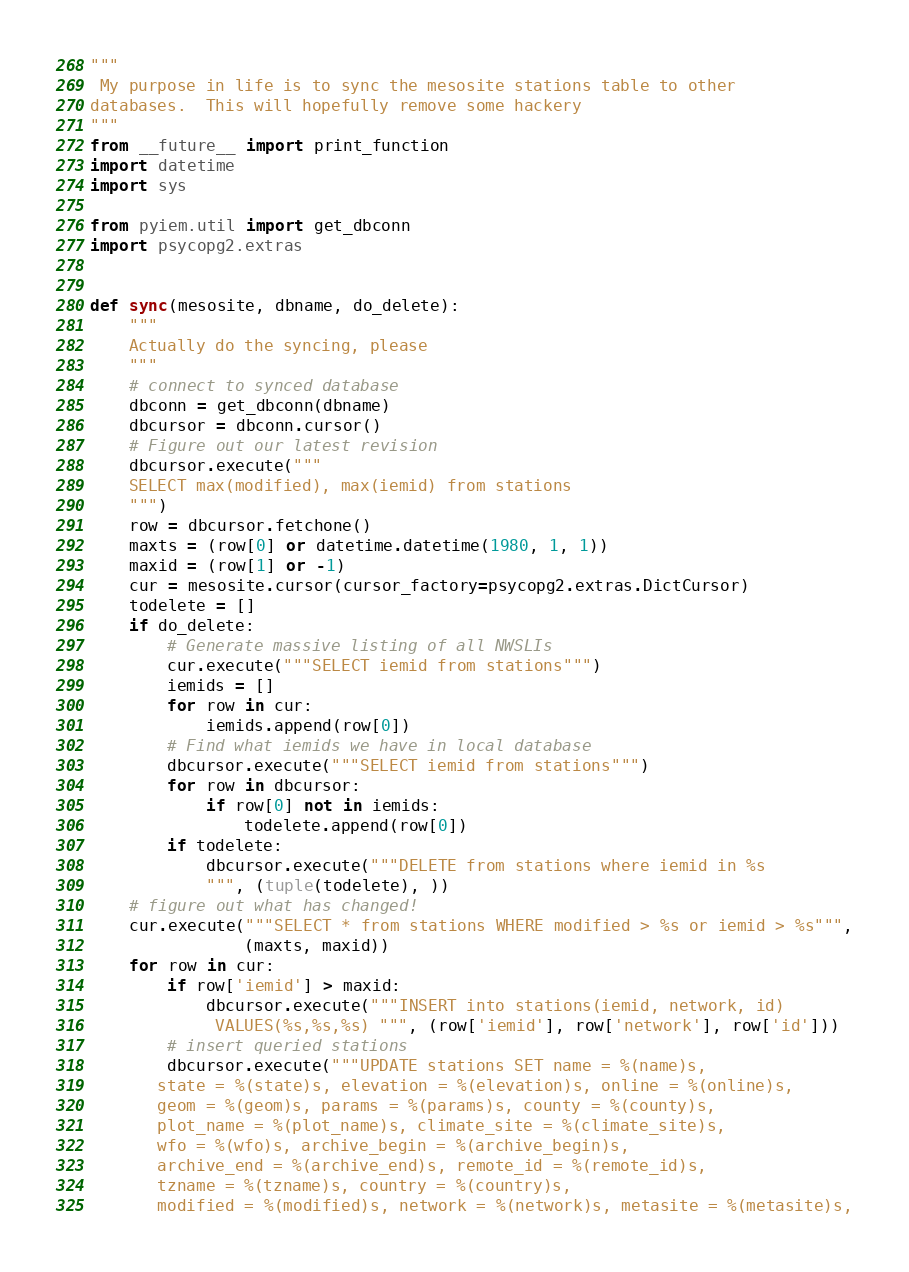<code> <loc_0><loc_0><loc_500><loc_500><_Python_>"""
 My purpose in life is to sync the mesosite stations table to other
databases.  This will hopefully remove some hackery
"""
from __future__ import print_function
import datetime
import sys

from pyiem.util import get_dbconn
import psycopg2.extras


def sync(mesosite, dbname, do_delete):
    """
    Actually do the syncing, please
    """
    # connect to synced database
    dbconn = get_dbconn(dbname)
    dbcursor = dbconn.cursor()
    # Figure out our latest revision
    dbcursor.execute("""
    SELECT max(modified), max(iemid) from stations
    """)
    row = dbcursor.fetchone()
    maxts = (row[0] or datetime.datetime(1980, 1, 1))
    maxid = (row[1] or -1)
    cur = mesosite.cursor(cursor_factory=psycopg2.extras.DictCursor)
    todelete = []
    if do_delete:
        # Generate massive listing of all NWSLIs
        cur.execute("""SELECT iemid from stations""")
        iemids = []
        for row in cur:
            iemids.append(row[0])
        # Find what iemids we have in local database
        dbcursor.execute("""SELECT iemid from stations""")
        for row in dbcursor:
            if row[0] not in iemids:
                todelete.append(row[0])
        if todelete:
            dbcursor.execute("""DELETE from stations where iemid in %s
            """, (tuple(todelete), ))
    # figure out what has changed!
    cur.execute("""SELECT * from stations WHERE modified > %s or iemid > %s""",
                (maxts, maxid))
    for row in cur:
        if row['iemid'] > maxid:
            dbcursor.execute("""INSERT into stations(iemid, network, id)
             VALUES(%s,%s,%s) """, (row['iemid'], row['network'], row['id']))
        # insert queried stations
        dbcursor.execute("""UPDATE stations SET name = %(name)s,
       state = %(state)s, elevation = %(elevation)s, online = %(online)s,
       geom = %(geom)s, params = %(params)s, county = %(county)s,
       plot_name = %(plot_name)s, climate_site = %(climate_site)s,
       wfo = %(wfo)s, archive_begin = %(archive_begin)s,
       archive_end = %(archive_end)s, remote_id = %(remote_id)s,
       tzname = %(tzname)s, country = %(country)s,
       modified = %(modified)s, network = %(network)s, metasite = %(metasite)s,</code> 